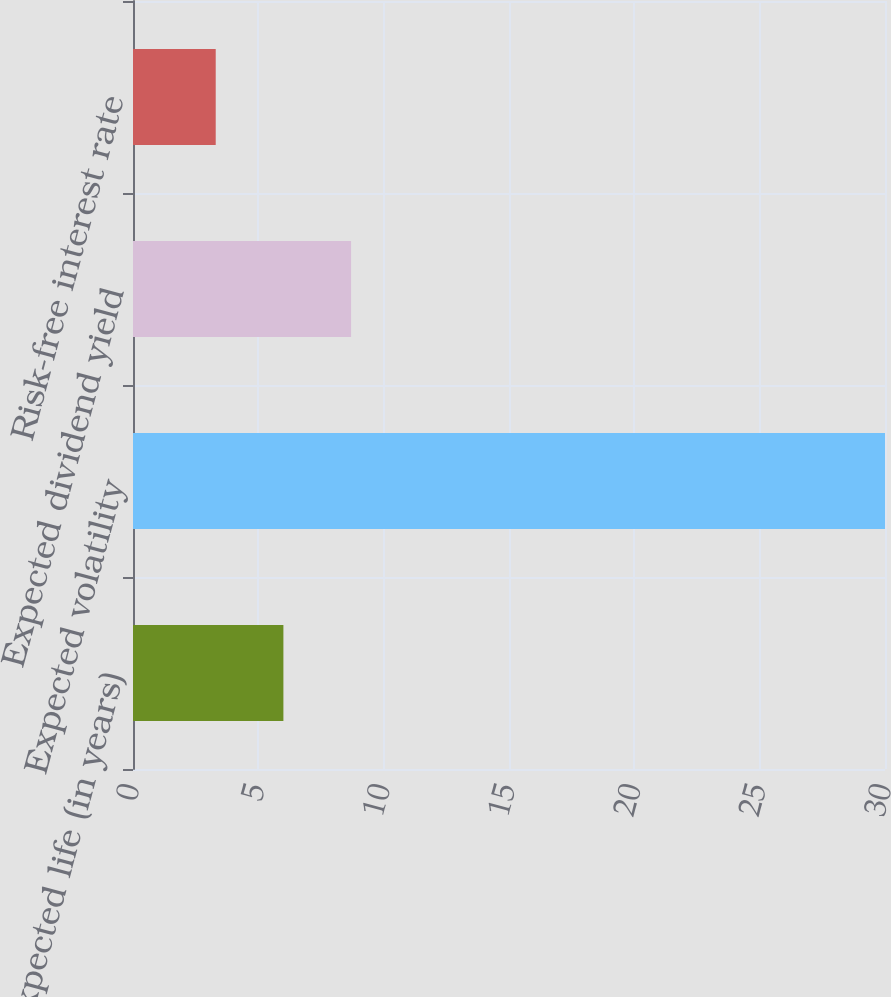Convert chart to OTSL. <chart><loc_0><loc_0><loc_500><loc_500><bar_chart><fcel>Expected life (in years)<fcel>Expected volatility<fcel>Expected dividend yield<fcel>Risk-free interest rate<nl><fcel>6<fcel>30<fcel>8.7<fcel>3.3<nl></chart> 